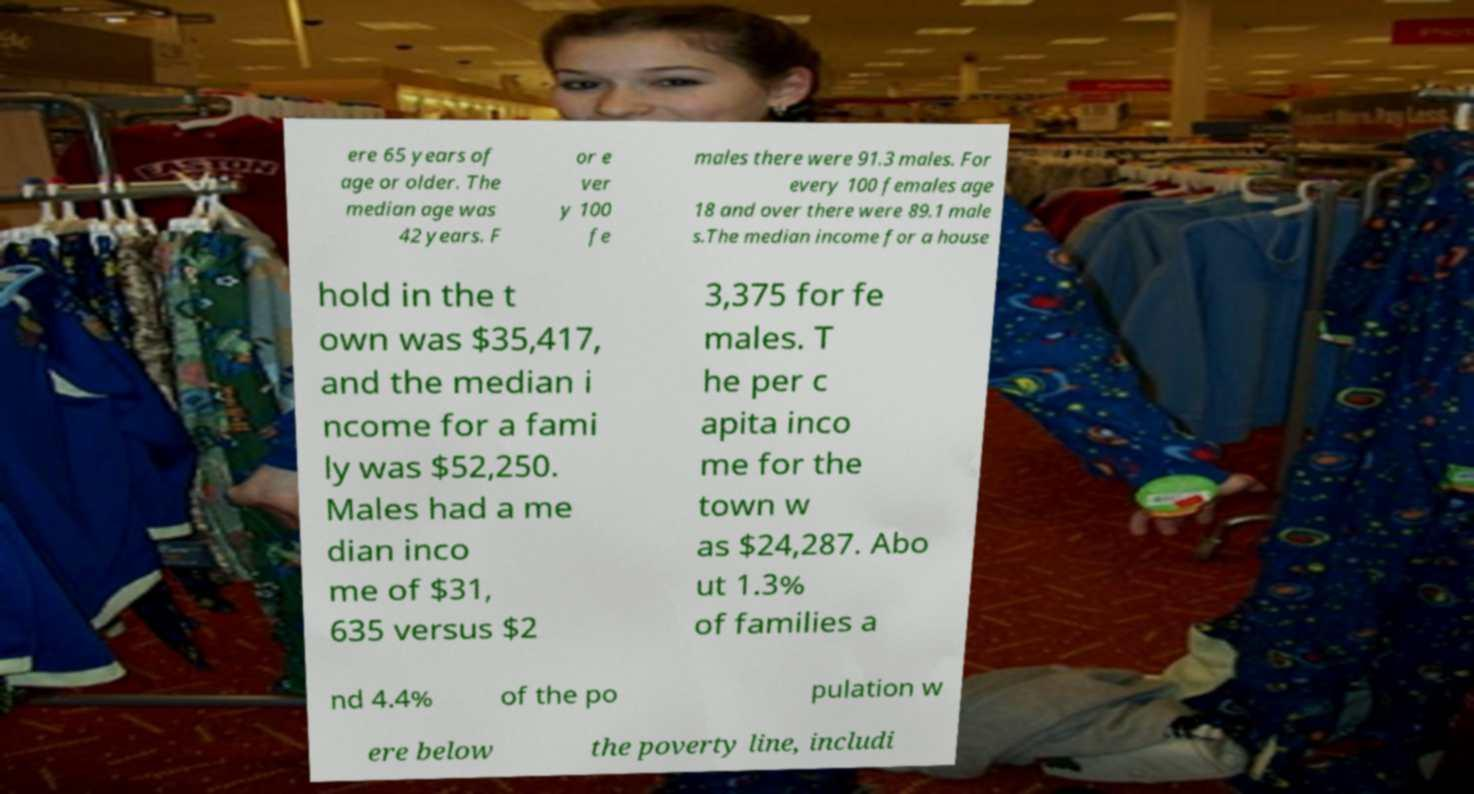Can you accurately transcribe the text from the provided image for me? ere 65 years of age or older. The median age was 42 years. F or e ver y 100 fe males there were 91.3 males. For every 100 females age 18 and over there were 89.1 male s.The median income for a house hold in the t own was $35,417, and the median i ncome for a fami ly was $52,250. Males had a me dian inco me of $31, 635 versus $2 3,375 for fe males. T he per c apita inco me for the town w as $24,287. Abo ut 1.3% of families a nd 4.4% of the po pulation w ere below the poverty line, includi 